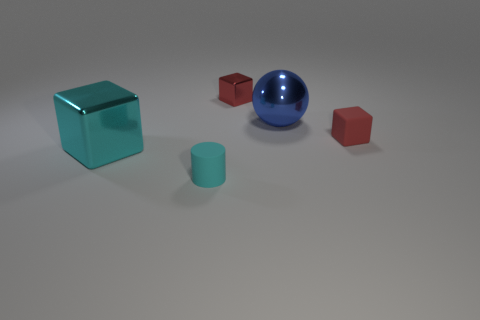Add 2 tiny red metal blocks. How many objects exist? 7 Subtract all cylinders. How many objects are left? 4 Add 1 red matte objects. How many red matte objects exist? 2 Subtract 0 brown balls. How many objects are left? 5 Subtract all large brown rubber balls. Subtract all cyan metallic cubes. How many objects are left? 4 Add 2 large blue spheres. How many large blue spheres are left? 3 